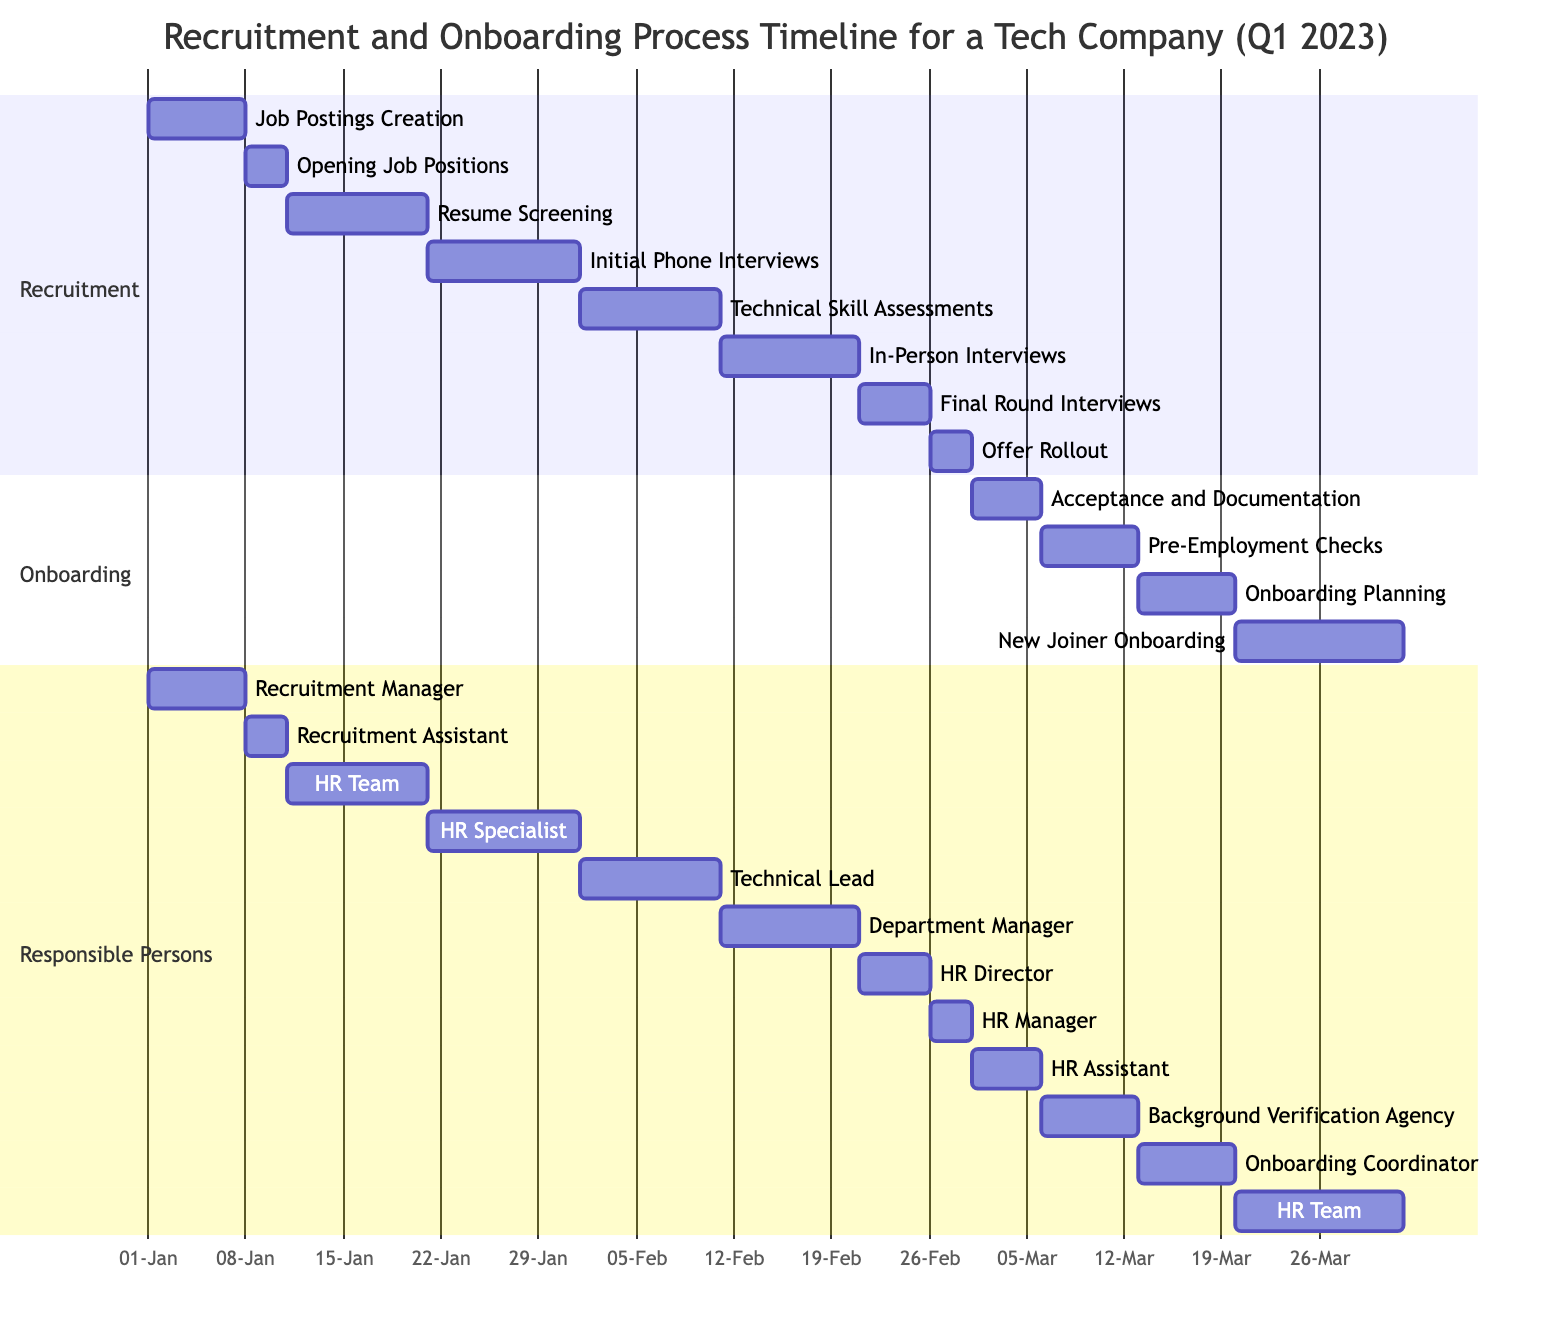What is the duration of the 'Job Postings Creation' task? The task 'Job Postings Creation' starts on 2023-01-01 and ends on 2023-01-07. Calculating the duration: 7 days.
Answer: 7 days Who is responsible for the 'Final Round Interviews'? The 'Final Round Interviews' task is assigned to the HR Director, as indicated in the responsible persons section where the task's timeline is also shown.
Answer: HR Director How many tasks occur in the Recruitment section? By counting the tasks listed in the Recruitment section, there are a total of 8 tasks: Job Postings Creation, Opening Job Positions, Resume Screening, Initial Phone Interviews, Technical Skill Assessments, In-Person Interviews, Final Round Interviews, and Offer Rollout.
Answer: 8 tasks Which task follows 'Technical Skill Assessments' directly? The 'In-Person Interviews' task comes after 'Technical Skill Assessments' as per the order and dependencies in the Gantt chart.
Answer: In-Person Interviews What is the start date of 'New Joiner Onboarding'? Looking at the chart, the 'New Joiner Onboarding' task starts on 2023-03-20, as indicated in the task's timeline data.
Answer: 2023-03-20 Which task has the longest duration in the Onboarding section? Among the tasks in the Onboarding section, 'New Joiner Onboarding' has the longest duration, running for 12 days from 2023-03-20 to 2023-03-31.
Answer: New Joiner Onboarding What is the end date of the 'Offer Rollout' task? The 'Offer Rollout' task is scheduled to end on 2023-02-28, as shown in the data provided for its timeline.
Answer: 2023-02-28 How many days after 'Resume Screening' does the 'Initial Phone Interviews' start? The 'Initial Phone Interviews' start after 'Resume Screening' finishes; 'Resume Screening' ends on 2023-01-20, and 'Initial Phone Interviews' begin on 2023-01-21, which is 1 day later.
Answer: 1 day What is the sequence of tasks leading to 'Acceptance and Documentation'? The sequence is: Offer Rollout, then Acceptance and Documentation. This can be followed in the Gantt chart's timeline.
Answer: Offer Rollout, Acceptance and Documentation 